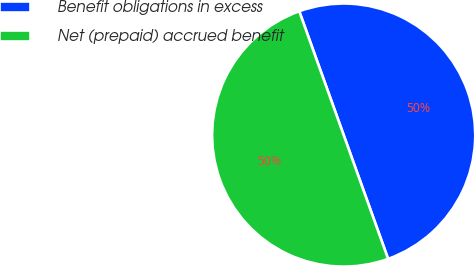Convert chart. <chart><loc_0><loc_0><loc_500><loc_500><pie_chart><fcel>Benefit obligations in excess<fcel>Net (prepaid) accrued benefit<nl><fcel>50.0%<fcel>50.0%<nl></chart> 